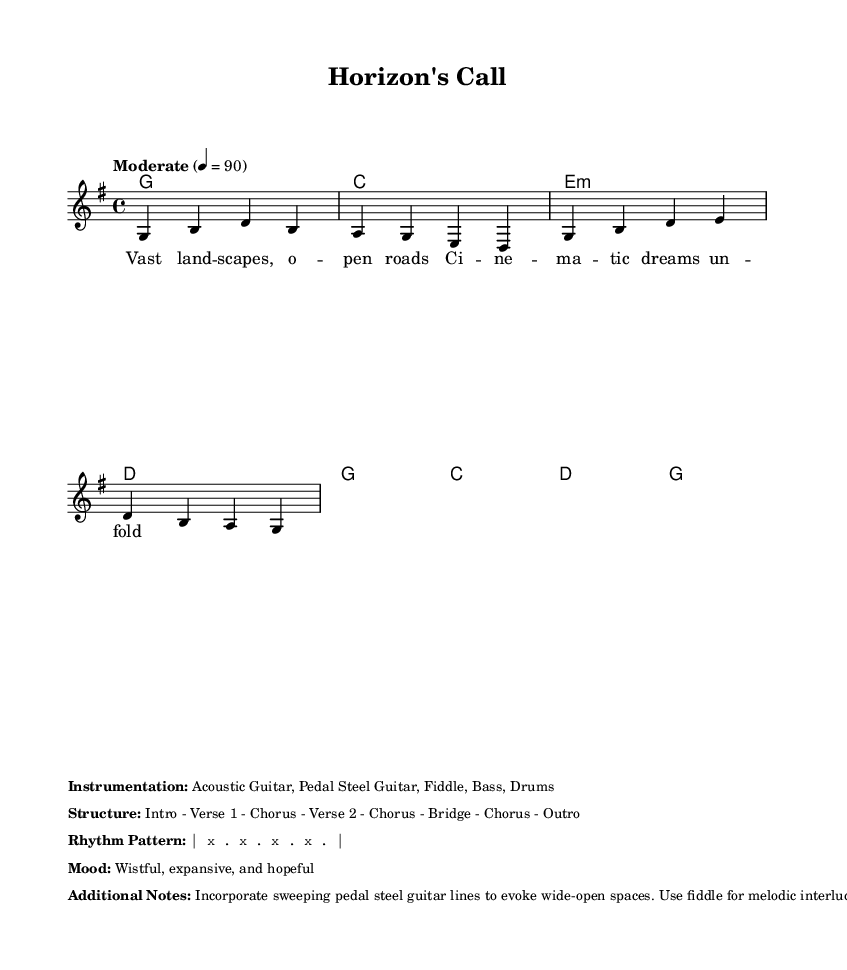What is the tempo of this music? The tempo marking indicates a speed of 90 beats per minute, which is noted in the score.
Answer: 90 What is the time signature of this piece? The time signature is shown as 4/4, meaning there are four beats per measure. This is confirmed in the global section of the code.
Answer: 4/4 What is the key signature of this music? The key signature is G major, represented by one sharp (F#). This is indicated in the global section of the code.
Answer: G major What is the mood described for this composition? The mood is characterized as wistful, expansive, and hopeful, as noted in the additional notes section of the score.
Answer: Wistful, expansive, and hopeful How many verses are in the structure of this music? The structure lists Verse 1 and Verse 2, indicating there are two verses in total. This can be confirmed in the structure markup.
Answer: 2 What instruments are used in this piece? The instrumentation includes Acoustic Guitar, Pedal Steel Guitar, Fiddle, Bass, and Drums, as detailed in the additional notes section.
Answer: Acoustic Guitar, Pedal Steel Guitar, Fiddle, Bass, Drums What element is suggested to evoke wide-open spaces? The score notes that sweeping pedal steel guitar lines are incorporated to evoke wide-open spaces, which suggests the musical texture aimed at creating that feeling.
Answer: Sweeping pedal steel guitar lines 